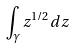Convert formula to latex. <formula><loc_0><loc_0><loc_500><loc_500>\int _ { \gamma } z ^ { 1 / 2 } d z</formula> 